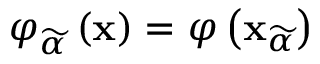Convert formula to latex. <formula><loc_0><loc_0><loc_500><loc_500>\varphi _ { \widetilde { \alpha } } \left ( x \right ) = \varphi \left ( x _ { \widetilde { \alpha } } \right )</formula> 